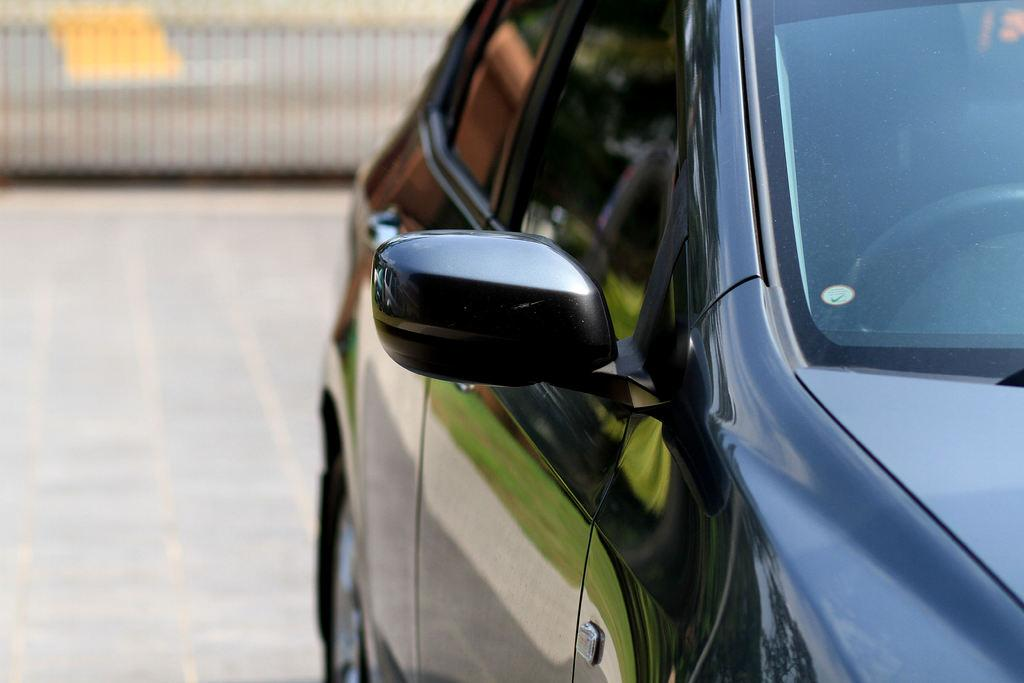What type of vehicle is in the image? There is a black color car in the image. Can you describe the background of the image? The background of the image is blurred. What type of peace symbol can be seen on the car in the image? There is no peace symbol present on the car in the image. What position is the car in the image? The position of the car cannot be determined from the image alone, as it only shows the car and a blurred background. 